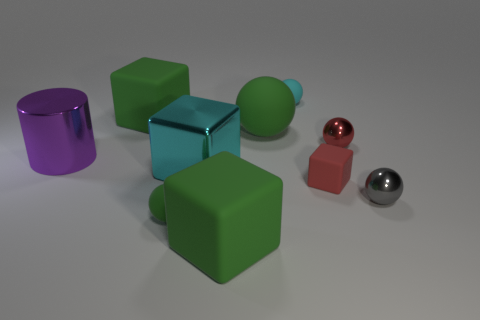Subtract all gray balls. How many balls are left? 4 Subtract all cyan balls. How many balls are left? 4 Subtract all blue spheres. Subtract all gray cylinders. How many spheres are left? 5 Subtract all cylinders. How many objects are left? 9 Add 2 gray metallic balls. How many gray metallic balls are left? 3 Add 1 tiny red shiny spheres. How many tiny red shiny spheres exist? 2 Subtract 0 purple spheres. How many objects are left? 10 Subtract all small purple matte cubes. Subtract all large cyan metallic cubes. How many objects are left? 9 